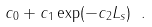Convert formula to latex. <formula><loc_0><loc_0><loc_500><loc_500>c _ { 0 } + c _ { 1 } \exp ( - c _ { 2 } L _ { s } ) \ .</formula> 